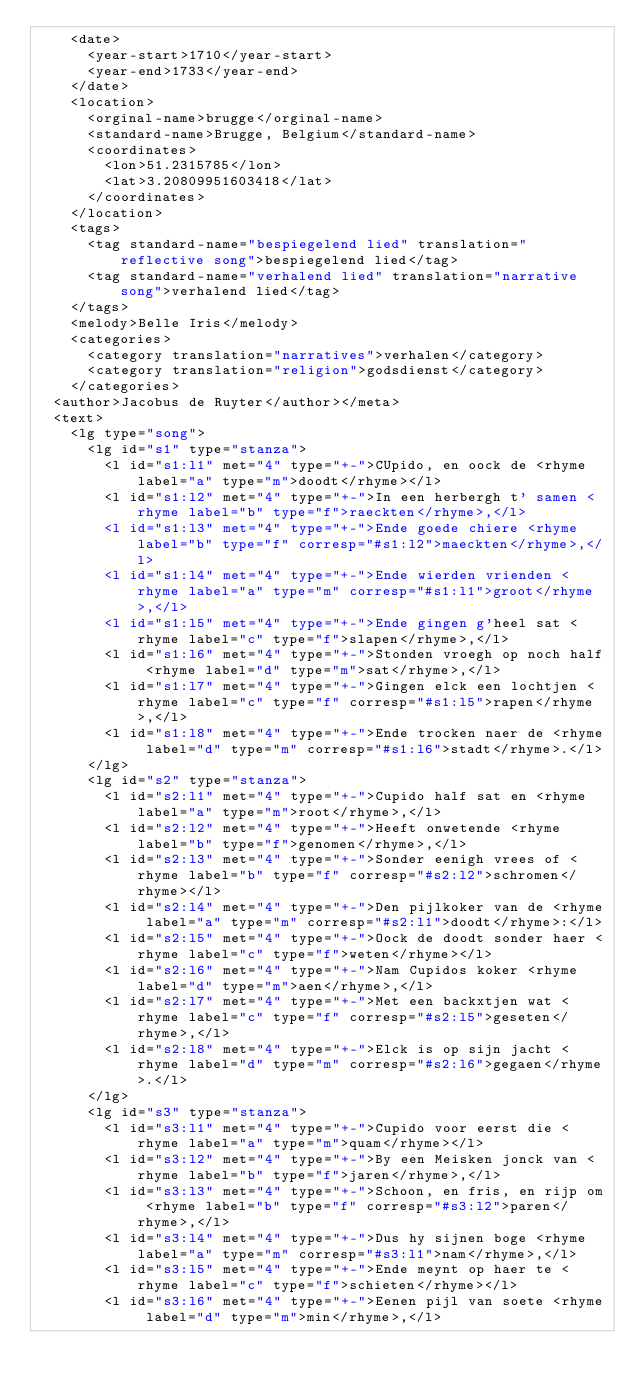Convert code to text. <code><loc_0><loc_0><loc_500><loc_500><_XML_>    <date>
      <year-start>1710</year-start>
      <year-end>1733</year-end>
    </date>
    <location>
      <orginal-name>brugge</orginal-name>
      <standard-name>Brugge, Belgium</standard-name>
      <coordinates>
        <lon>51.2315785</lon>
        <lat>3.20809951603418</lat>
      </coordinates>
    </location>
    <tags>
      <tag standard-name="bespiegelend lied" translation="reflective song">bespiegelend lied</tag>
      <tag standard-name="verhalend lied" translation="narrative song">verhalend lied</tag>
    </tags>
    <melody>Belle Iris</melody>
    <categories>
      <category translation="narratives">verhalen</category>
      <category translation="religion">godsdienst</category>
    </categories>
  <author>Jacobus de Ruyter</author></meta>
  <text>
    <lg type="song">
      <lg id="s1" type="stanza">
        <l id="s1:l1" met="4" type="+-">CUpido, en oock de <rhyme label="a" type="m">doodt</rhyme></l>
        <l id="s1:l2" met="4" type="+-">In een herbergh t' samen <rhyme label="b" type="f">raeckten</rhyme>,</l>
        <l id="s1:l3" met="4" type="+-">Ende goede chiere <rhyme label="b" type="f" corresp="#s1:l2">maeckten</rhyme>,</l>
        <l id="s1:l4" met="4" type="+-">Ende wierden vrienden <rhyme label="a" type="m" corresp="#s1:l1">groot</rhyme>,</l>
        <l id="s1:l5" met="4" type="+-">Ende gingen g'heel sat <rhyme label="c" type="f">slapen</rhyme>,</l>
        <l id="s1:l6" met="4" type="+-">Stonden vroegh op noch half <rhyme label="d" type="m">sat</rhyme>,</l>
        <l id="s1:l7" met="4" type="+-">Gingen elck een lochtjen <rhyme label="c" type="f" corresp="#s1:l5">rapen</rhyme>,</l>
        <l id="s1:l8" met="4" type="+-">Ende trocken naer de <rhyme label="d" type="m" corresp="#s1:l6">stadt</rhyme>.</l>
      </lg>
      <lg id="s2" type="stanza">
        <l id="s2:l1" met="4" type="+-">Cupido half sat en <rhyme label="a" type="m">root</rhyme>,</l>
        <l id="s2:l2" met="4" type="+-">Heeft onwetende <rhyme label="b" type="f">genomen</rhyme>,</l>
        <l id="s2:l3" met="4" type="+-">Sonder eenigh vrees of <rhyme label="b" type="f" corresp="#s2:l2">schromen</rhyme></l>
        <l id="s2:l4" met="4" type="+-">Den pijlkoker van de <rhyme label="a" type="m" corresp="#s2:l1">doodt</rhyme>:</l>
        <l id="s2:l5" met="4" type="+-">Oock de doodt sonder haer <rhyme label="c" type="f">weten</rhyme></l>
        <l id="s2:l6" met="4" type="+-">Nam Cupidos koker <rhyme label="d" type="m">aen</rhyme>,</l>
        <l id="s2:l7" met="4" type="+-">Met een backxtjen wat <rhyme label="c" type="f" corresp="#s2:l5">geseten</rhyme>,</l>
        <l id="s2:l8" met="4" type="+-">Elck is op sijn jacht <rhyme label="d" type="m" corresp="#s2:l6">gegaen</rhyme>.</l>
      </lg>
      <lg id="s3" type="stanza">
        <l id="s3:l1" met="4" type="+-">Cupido voor eerst die <rhyme label="a" type="m">quam</rhyme></l>
        <l id="s3:l2" met="4" type="+-">By een Meisken jonck van <rhyme label="b" type="f">jaren</rhyme>,</l>
        <l id="s3:l3" met="4" type="+-">Schoon, en fris, en rijp om <rhyme label="b" type="f" corresp="#s3:l2">paren</rhyme>,</l>
        <l id="s3:l4" met="4" type="+-">Dus hy sijnen boge <rhyme label="a" type="m" corresp="#s3:l1">nam</rhyme>,</l>
        <l id="s3:l5" met="4" type="+-">Ende meynt op haer te <rhyme label="c" type="f">schieten</rhyme></l>
        <l id="s3:l6" met="4" type="+-">Eenen pijl van soete <rhyme label="d" type="m">min</rhyme>,</l></code> 